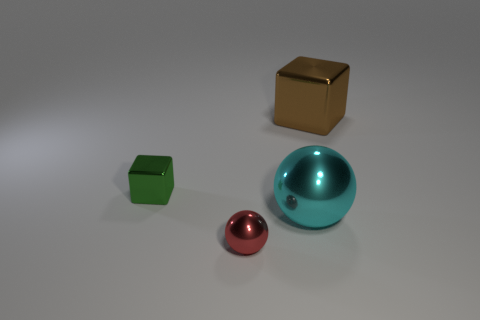Are there any large balls in front of the red ball?
Offer a very short reply. No. Are there any tiny cyan metal things of the same shape as the green object?
Provide a succinct answer. No. What shape is the green metallic thing that is the same size as the red sphere?
Make the answer very short. Cube. How many objects are either metal things in front of the big brown object or brown cubes?
Your answer should be compact. 4. Is the color of the small ball the same as the big metallic ball?
Give a very brief answer. No. How big is the thing in front of the cyan shiny object?
Keep it short and to the point. Small. Are there any brown objects that have the same size as the green block?
Give a very brief answer. No. There is a cube in front of the brown metal block; is its size the same as the tiny red object?
Your answer should be compact. Yes. The red sphere is what size?
Ensure brevity in your answer.  Small. What is the color of the metallic ball that is to the left of the big thing that is in front of the small thing that is to the left of the small metal sphere?
Offer a terse response. Red. 